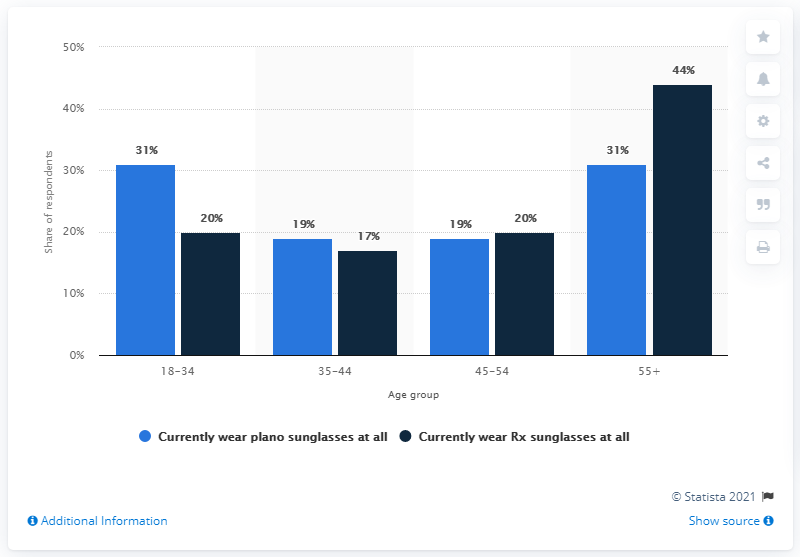List a handful of essential elements in this visual. The highest percentage in the navy blue bar is 44%. The sum of the highest and lowest values of the light blue bar is 50. 